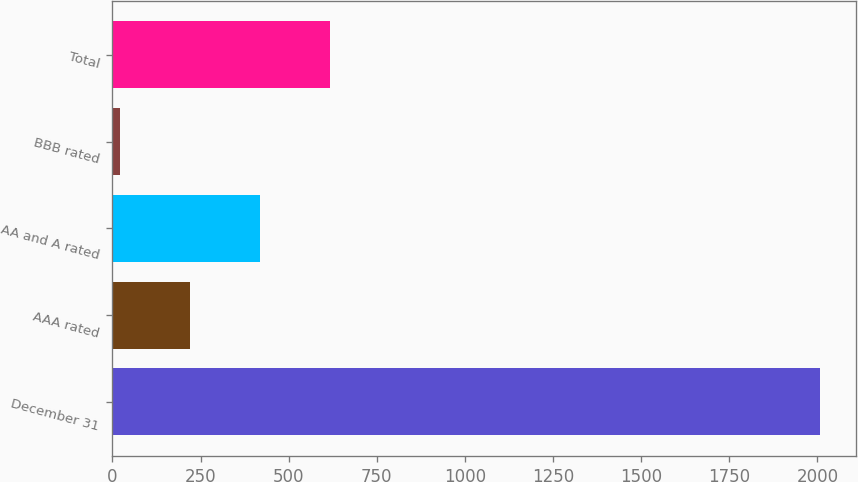Convert chart to OTSL. <chart><loc_0><loc_0><loc_500><loc_500><bar_chart><fcel>December 31<fcel>AAA rated<fcel>AA and A rated<fcel>BBB rated<fcel>Total<nl><fcel>2008<fcel>220.24<fcel>418.88<fcel>21.6<fcel>617.52<nl></chart> 